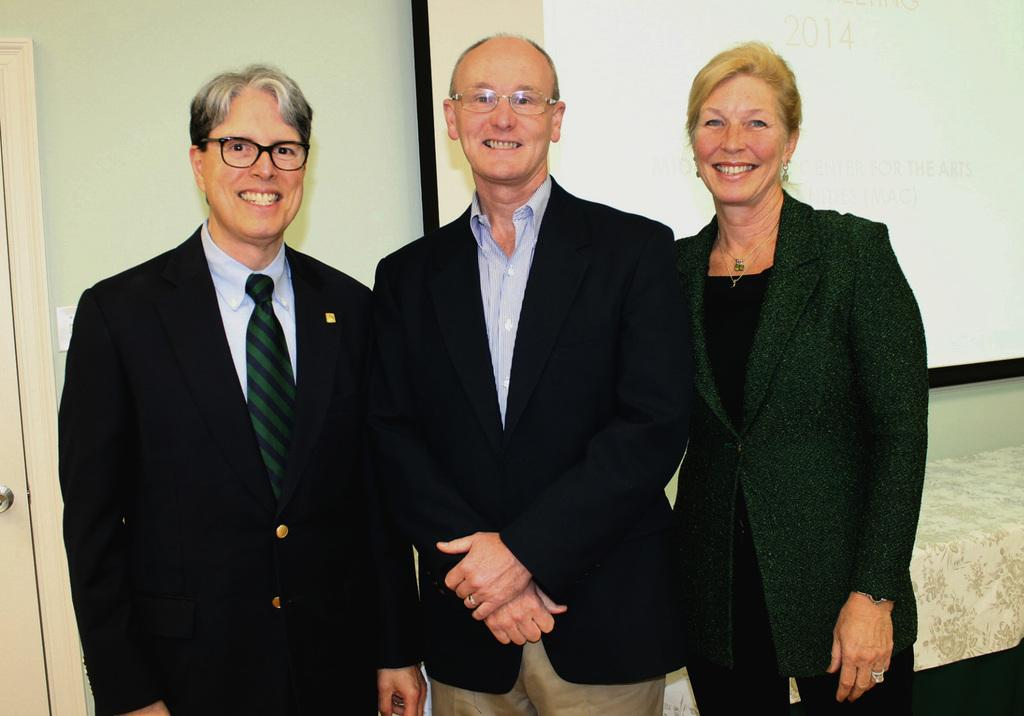How many people are in the image? There are three people standing in the image. What are the people wearing? The people are wearing suits. What can be seen on the display in the image? There is a projector display in the image. Where is the door located in the image? There is a door visible in the image. Is there any snow visible in the image? No, there is no snow present in the image. What impulse might have led the people to gather in the image? The provided facts do not give any information about the reason or impulse behind the gathering of the people in the image. 